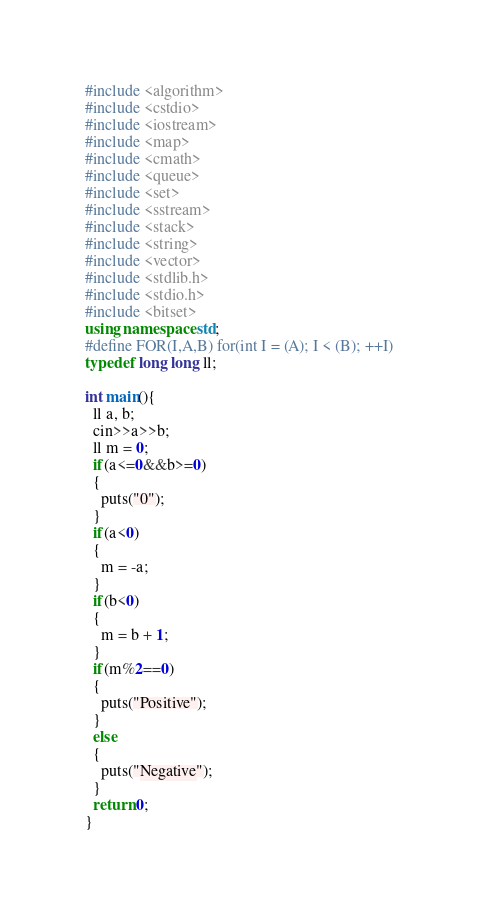Convert code to text. <code><loc_0><loc_0><loc_500><loc_500><_C++_>#include <algorithm>
#include <cstdio>
#include <iostream>
#include <map>
#include <cmath>
#include <queue>
#include <set>
#include <sstream>
#include <stack>
#include <string>
#include <vector>
#include <stdlib.h>
#include <stdio.h>
#include <bitset>
using namespace std;
#define FOR(I,A,B) for(int I = (A); I < (B); ++I)
typedef long long ll;

int main(){
  ll a, b;
  cin>>a>>b;
  ll m = 0;
  if(a<=0&&b>=0)
  {
    puts("0");
  }
  if(a<0)
  {
    m = -a;
  }
  if(b<0)
  {
    m = b + 1;
  }
  if(m%2==0)
  {
    puts("Positive");
  }
  else
  {
    puts("Negative");
  }
  return 0;
}
</code> 